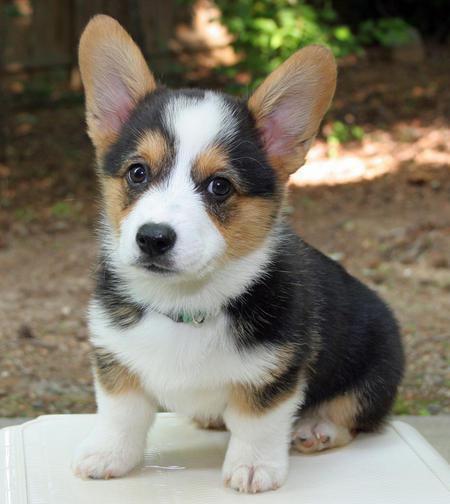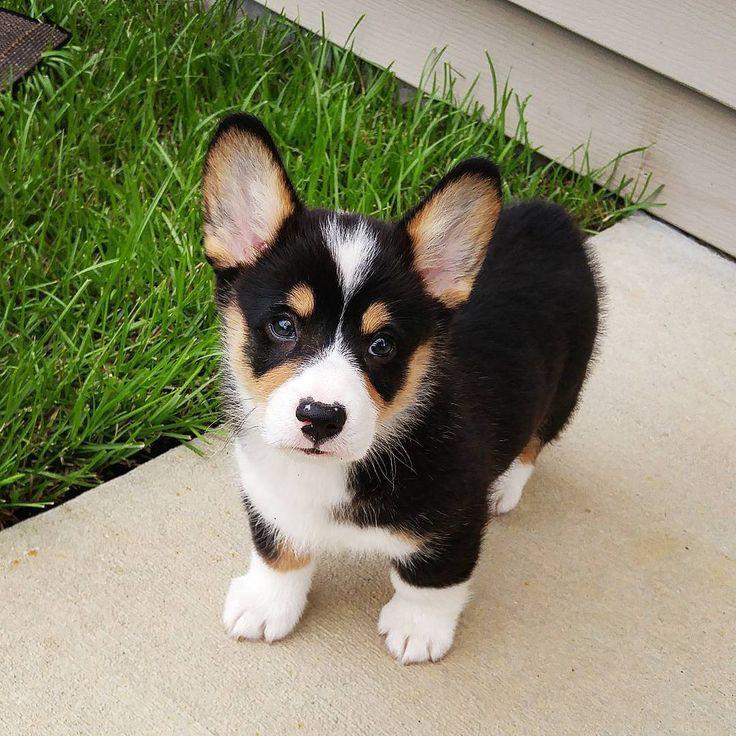The first image is the image on the left, the second image is the image on the right. For the images displayed, is the sentence "Both images contain a single camera-facing dog, and both images contain tri-color black, white and tan dogs." factually correct? Answer yes or no. Yes. The first image is the image on the left, the second image is the image on the right. For the images displayed, is the sentence "At least one dog is showing its tongue." factually correct? Answer yes or no. No. 